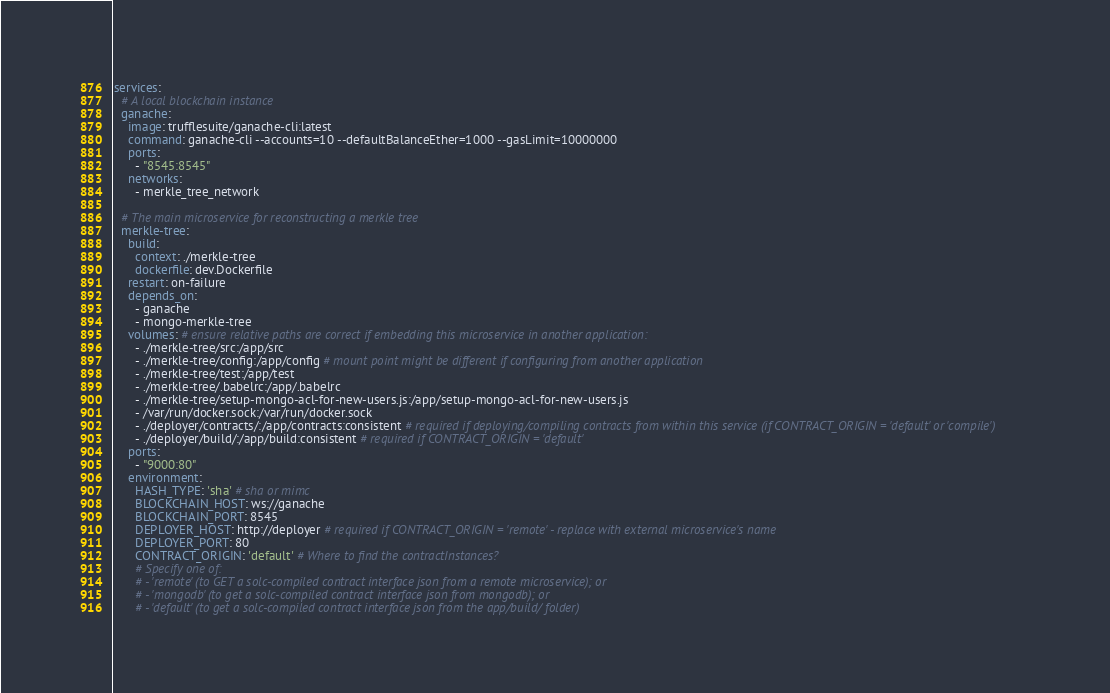<code> <loc_0><loc_0><loc_500><loc_500><_YAML_>
services:
  # A local blockchain instance
  ganache:
    image: trufflesuite/ganache-cli:latest
    command: ganache-cli --accounts=10 --defaultBalanceEther=1000 --gasLimit=10000000
    ports:
      - "8545:8545"
    networks:
      - merkle_tree_network

  # The main microservice for reconstructing a merkle tree
  merkle-tree:
    build:
      context: ./merkle-tree
      dockerfile: dev.Dockerfile
    restart: on-failure
    depends_on:
      - ganache
      - mongo-merkle-tree
    volumes: # ensure relative paths are correct if embedding this microservice in another application:
      - ./merkle-tree/src:/app/src
      - ./merkle-tree/config:/app/config # mount point might be different if configuring from another application
      - ./merkle-tree/test:/app/test
      - ./merkle-tree/.babelrc:/app/.babelrc
      - ./merkle-tree/setup-mongo-acl-for-new-users.js:/app/setup-mongo-acl-for-new-users.js
      - /var/run/docker.sock:/var/run/docker.sock
      - ./deployer/contracts/:/app/contracts:consistent # required if deploying/compiling contracts from within this service (if CONTRACT_ORIGIN = 'default' or 'compile')
      - ./deployer/build/:/app/build:consistent # required if CONTRACT_ORIGIN = 'default'
    ports:
      - "9000:80"
    environment:
      HASH_TYPE: 'sha' # sha or mimc
      BLOCKCHAIN_HOST: ws://ganache
      BLOCKCHAIN_PORT: 8545
      DEPLOYER_HOST: http://deployer # required if CONTRACT_ORIGIN = 'remote' - replace with external microservice's name
      DEPLOYER_PORT: 80
      CONTRACT_ORIGIN: 'default' # Where to find the contractInstances?
      # Specify one of:
      # - 'remote' (to GET a solc-compiled contract interface json from a remote microservice); or
      # - 'mongodb' (to get a solc-compiled contract interface json from mongodb); or
      # - 'default' (to get a solc-compiled contract interface json from the app/build/ folder)</code> 